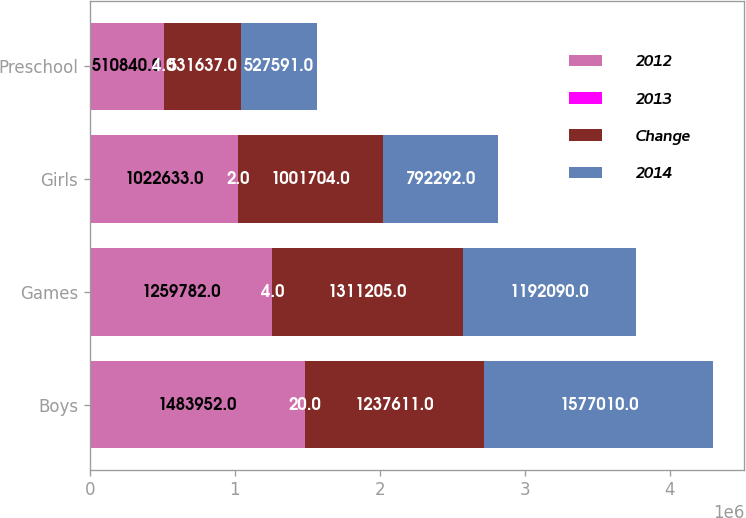<chart> <loc_0><loc_0><loc_500><loc_500><stacked_bar_chart><ecel><fcel>Boys<fcel>Games<fcel>Girls<fcel>Preschool<nl><fcel>2012<fcel>1.48395e+06<fcel>1.25978e+06<fcel>1.02263e+06<fcel>510840<nl><fcel>2013<fcel>20<fcel>4<fcel>2<fcel>4<nl><fcel>Change<fcel>1.23761e+06<fcel>1.3112e+06<fcel>1.0017e+06<fcel>531637<nl><fcel>2014<fcel>1.57701e+06<fcel>1.19209e+06<fcel>792292<fcel>527591<nl></chart> 